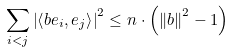<formula> <loc_0><loc_0><loc_500><loc_500>\sum _ { i < j } \left | \left \langle b e _ { i } , e _ { j } \right \rangle \right | ^ { 2 } \leq n \cdot \left ( \left \| b \right \| ^ { 2 } - 1 \right )</formula> 